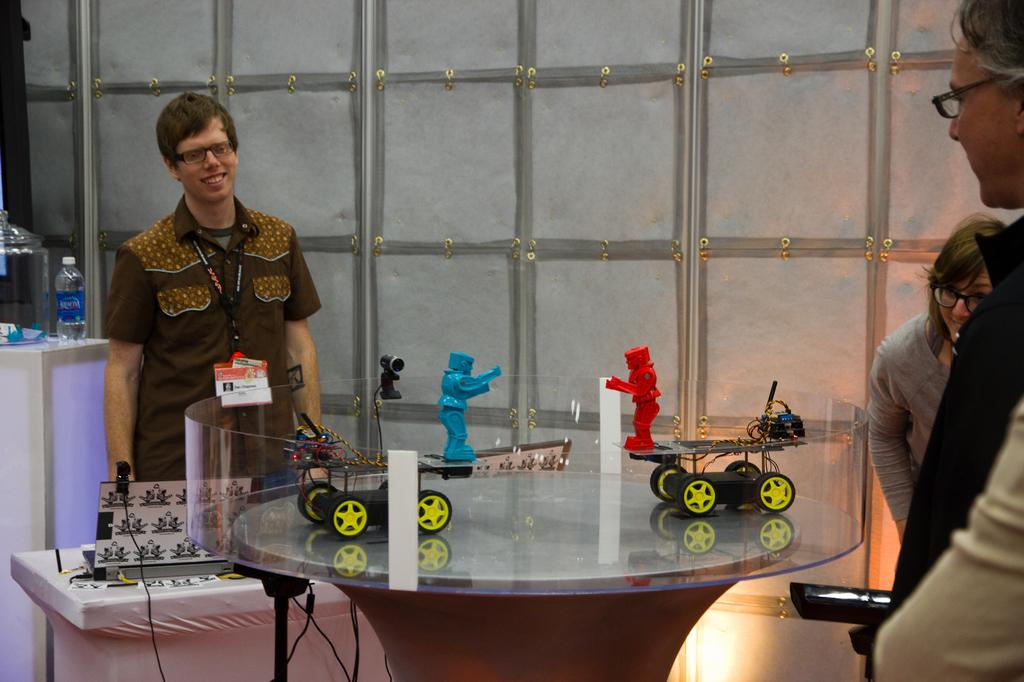What is happening in the image? There are people around a table. What can be seen on the table? There are toys on the table. What type of animal is sitting at the table with the people? There is no animal present in the image; it only shows people and toys on the table. What kind of border is surrounding the table in the image? There is no border surrounding the table in the image. 